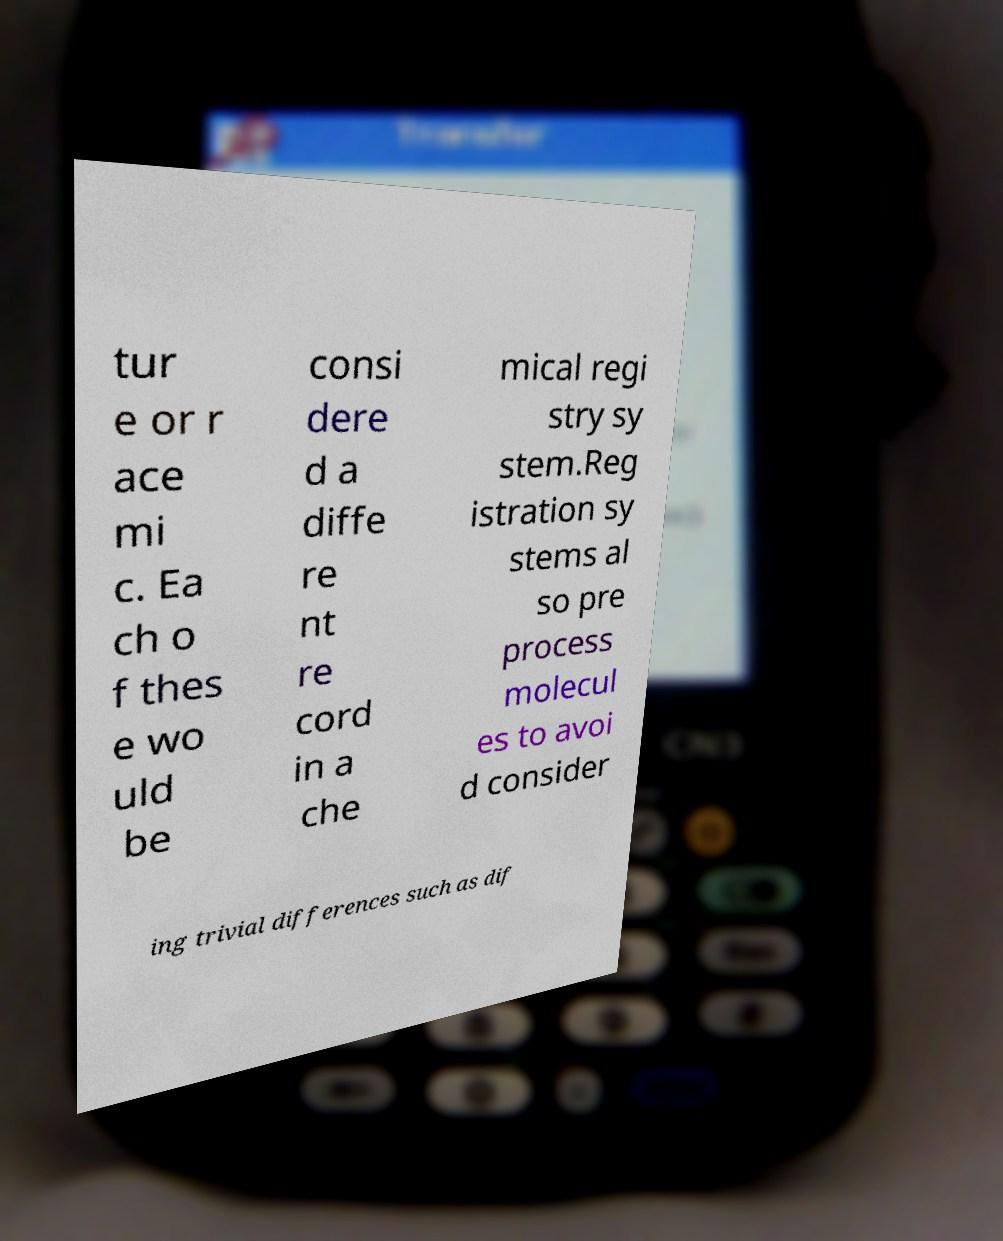Please identify and transcribe the text found in this image. tur e or r ace mi c. Ea ch o f thes e wo uld be consi dere d a diffe re nt re cord in a che mical regi stry sy stem.Reg istration sy stems al so pre process molecul es to avoi d consider ing trivial differences such as dif 